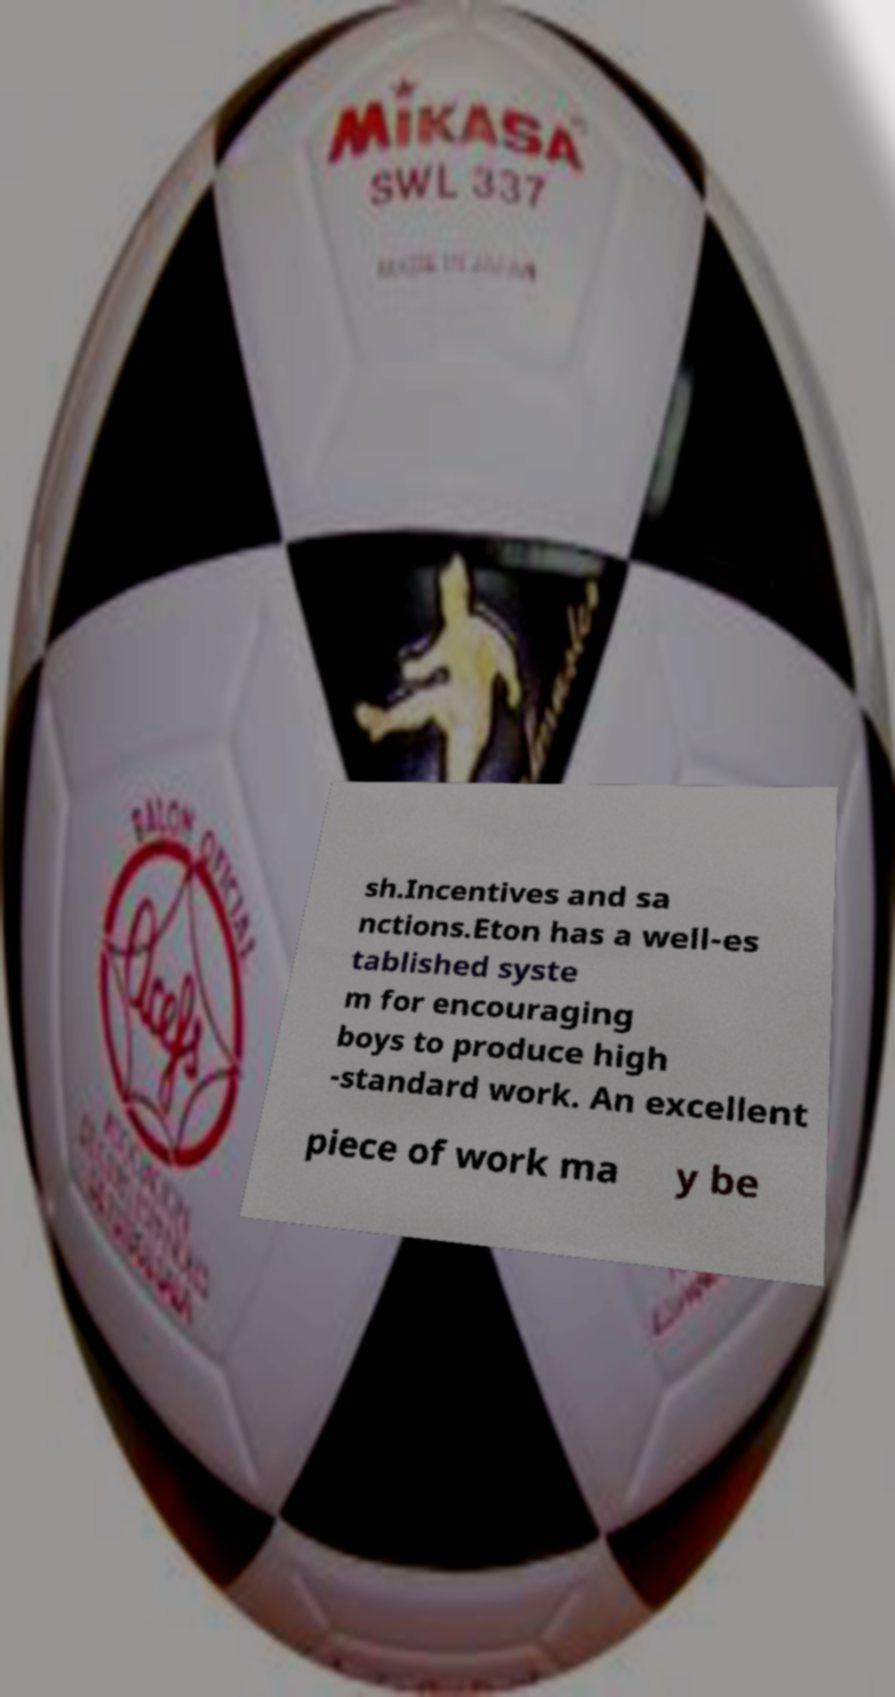Can you accurately transcribe the text from the provided image for me? sh.Incentives and sa nctions.Eton has a well-es tablished syste m for encouraging boys to produce high -standard work. An excellent piece of work ma y be 